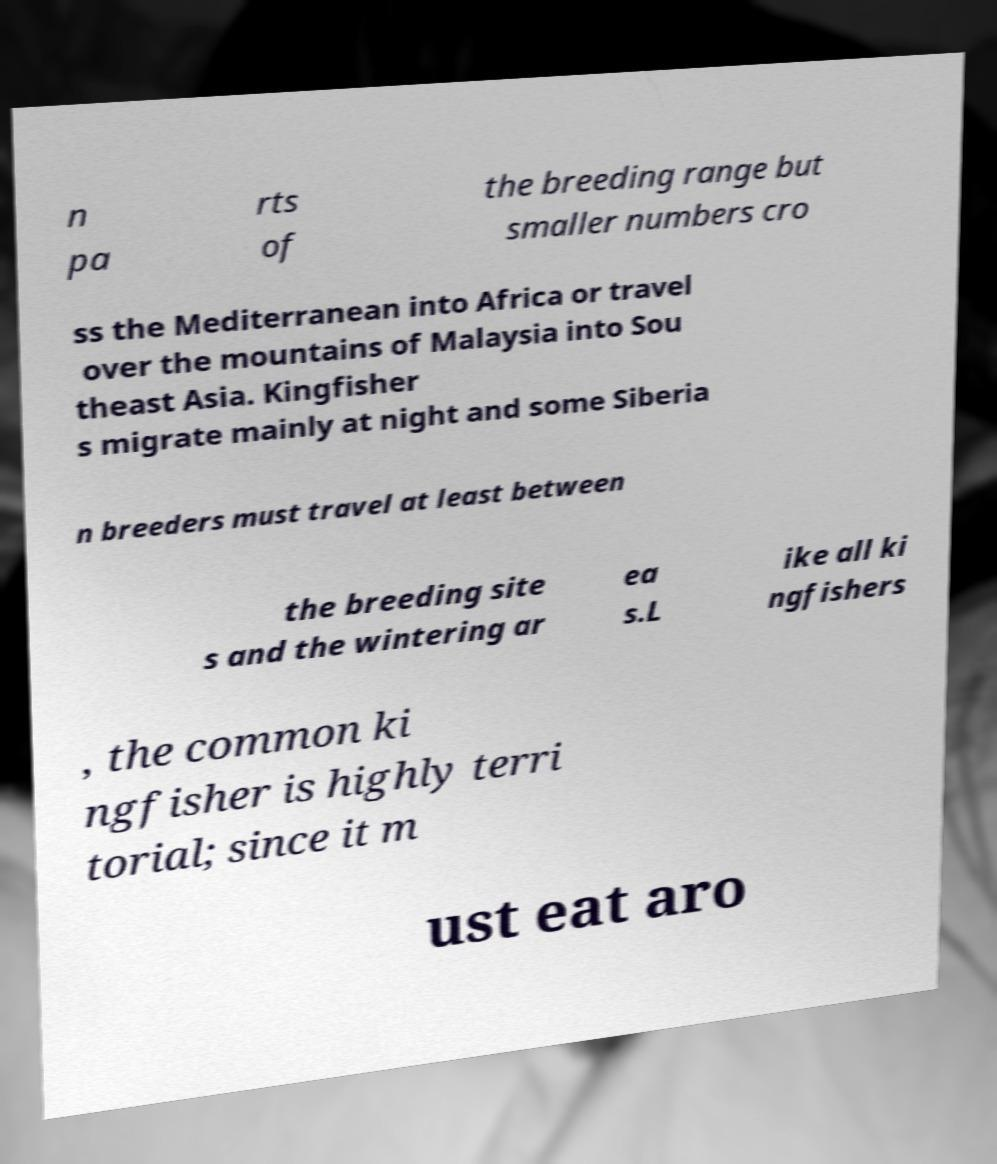Please identify and transcribe the text found in this image. n pa rts of the breeding range but smaller numbers cro ss the Mediterranean into Africa or travel over the mountains of Malaysia into Sou theast Asia. Kingfisher s migrate mainly at night and some Siberia n breeders must travel at least between the breeding site s and the wintering ar ea s.L ike all ki ngfishers , the common ki ngfisher is highly terri torial; since it m ust eat aro 